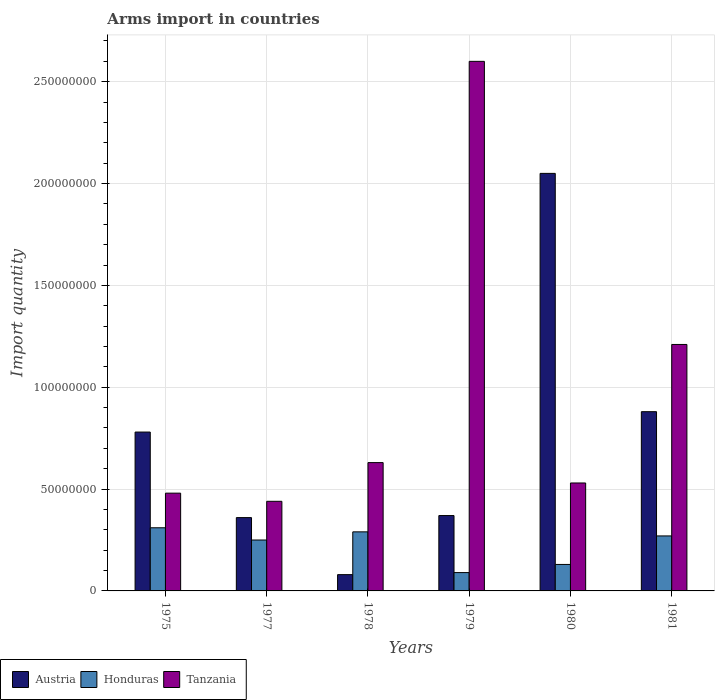Are the number of bars on each tick of the X-axis equal?
Your answer should be compact. Yes. What is the label of the 5th group of bars from the left?
Provide a short and direct response. 1980. In how many cases, is the number of bars for a given year not equal to the number of legend labels?
Offer a terse response. 0. What is the total arms import in Austria in 1977?
Make the answer very short. 3.60e+07. Across all years, what is the maximum total arms import in Tanzania?
Offer a very short reply. 2.60e+08. Across all years, what is the minimum total arms import in Austria?
Offer a terse response. 8.00e+06. In which year was the total arms import in Honduras maximum?
Your answer should be very brief. 1975. In which year was the total arms import in Austria minimum?
Your response must be concise. 1978. What is the total total arms import in Austria in the graph?
Keep it short and to the point. 4.52e+08. What is the difference between the total arms import in Austria in 1977 and that in 1980?
Your answer should be compact. -1.69e+08. What is the difference between the total arms import in Austria in 1977 and the total arms import in Tanzania in 1979?
Provide a succinct answer. -2.24e+08. What is the average total arms import in Austria per year?
Give a very brief answer. 7.53e+07. In the year 1975, what is the difference between the total arms import in Honduras and total arms import in Austria?
Keep it short and to the point. -4.70e+07. What is the ratio of the total arms import in Honduras in 1975 to that in 1978?
Your answer should be compact. 1.07. Is the total arms import in Honduras in 1977 less than that in 1979?
Your answer should be very brief. No. What is the difference between the highest and the second highest total arms import in Austria?
Give a very brief answer. 1.17e+08. What is the difference between the highest and the lowest total arms import in Honduras?
Provide a short and direct response. 2.20e+07. In how many years, is the total arms import in Tanzania greater than the average total arms import in Tanzania taken over all years?
Your response must be concise. 2. Is the sum of the total arms import in Honduras in 1978 and 1980 greater than the maximum total arms import in Tanzania across all years?
Make the answer very short. No. What does the 1st bar from the right in 1979 represents?
Ensure brevity in your answer.  Tanzania. Is it the case that in every year, the sum of the total arms import in Austria and total arms import in Tanzania is greater than the total arms import in Honduras?
Make the answer very short. Yes. How many bars are there?
Your answer should be very brief. 18. How many years are there in the graph?
Ensure brevity in your answer.  6. What is the difference between two consecutive major ticks on the Y-axis?
Your answer should be very brief. 5.00e+07. Does the graph contain grids?
Your answer should be very brief. Yes. Where does the legend appear in the graph?
Your answer should be very brief. Bottom left. How are the legend labels stacked?
Make the answer very short. Horizontal. What is the title of the graph?
Your answer should be very brief. Arms import in countries. What is the label or title of the Y-axis?
Give a very brief answer. Import quantity. What is the Import quantity of Austria in 1975?
Ensure brevity in your answer.  7.80e+07. What is the Import quantity in Honduras in 1975?
Keep it short and to the point. 3.10e+07. What is the Import quantity of Tanzania in 1975?
Offer a very short reply. 4.80e+07. What is the Import quantity in Austria in 1977?
Offer a terse response. 3.60e+07. What is the Import quantity of Honduras in 1977?
Ensure brevity in your answer.  2.50e+07. What is the Import quantity in Tanzania in 1977?
Keep it short and to the point. 4.40e+07. What is the Import quantity of Austria in 1978?
Give a very brief answer. 8.00e+06. What is the Import quantity in Honduras in 1978?
Offer a terse response. 2.90e+07. What is the Import quantity of Tanzania in 1978?
Provide a succinct answer. 6.30e+07. What is the Import quantity of Austria in 1979?
Keep it short and to the point. 3.70e+07. What is the Import quantity in Honduras in 1979?
Provide a succinct answer. 9.00e+06. What is the Import quantity of Tanzania in 1979?
Your response must be concise. 2.60e+08. What is the Import quantity in Austria in 1980?
Provide a short and direct response. 2.05e+08. What is the Import quantity of Honduras in 1980?
Make the answer very short. 1.30e+07. What is the Import quantity of Tanzania in 1980?
Provide a succinct answer. 5.30e+07. What is the Import quantity in Austria in 1981?
Make the answer very short. 8.80e+07. What is the Import quantity of Honduras in 1981?
Offer a very short reply. 2.70e+07. What is the Import quantity of Tanzania in 1981?
Make the answer very short. 1.21e+08. Across all years, what is the maximum Import quantity in Austria?
Provide a succinct answer. 2.05e+08. Across all years, what is the maximum Import quantity of Honduras?
Your answer should be very brief. 3.10e+07. Across all years, what is the maximum Import quantity of Tanzania?
Your response must be concise. 2.60e+08. Across all years, what is the minimum Import quantity of Honduras?
Provide a succinct answer. 9.00e+06. Across all years, what is the minimum Import quantity in Tanzania?
Your answer should be compact. 4.40e+07. What is the total Import quantity of Austria in the graph?
Your answer should be compact. 4.52e+08. What is the total Import quantity of Honduras in the graph?
Your response must be concise. 1.34e+08. What is the total Import quantity in Tanzania in the graph?
Provide a succinct answer. 5.89e+08. What is the difference between the Import quantity in Austria in 1975 and that in 1977?
Ensure brevity in your answer.  4.20e+07. What is the difference between the Import quantity of Tanzania in 1975 and that in 1977?
Keep it short and to the point. 4.00e+06. What is the difference between the Import quantity in Austria in 1975 and that in 1978?
Make the answer very short. 7.00e+07. What is the difference between the Import quantity in Honduras in 1975 and that in 1978?
Offer a terse response. 2.00e+06. What is the difference between the Import quantity in Tanzania in 1975 and that in 1978?
Keep it short and to the point. -1.50e+07. What is the difference between the Import quantity of Austria in 1975 and that in 1979?
Make the answer very short. 4.10e+07. What is the difference between the Import quantity of Honduras in 1975 and that in 1979?
Make the answer very short. 2.20e+07. What is the difference between the Import quantity in Tanzania in 1975 and that in 1979?
Your response must be concise. -2.12e+08. What is the difference between the Import quantity in Austria in 1975 and that in 1980?
Offer a terse response. -1.27e+08. What is the difference between the Import quantity of Honduras in 1975 and that in 1980?
Ensure brevity in your answer.  1.80e+07. What is the difference between the Import quantity in Tanzania in 1975 and that in 1980?
Give a very brief answer. -5.00e+06. What is the difference between the Import quantity in Austria in 1975 and that in 1981?
Your answer should be very brief. -1.00e+07. What is the difference between the Import quantity in Tanzania in 1975 and that in 1981?
Provide a succinct answer. -7.30e+07. What is the difference between the Import quantity of Austria in 1977 and that in 1978?
Offer a terse response. 2.80e+07. What is the difference between the Import quantity of Tanzania in 1977 and that in 1978?
Ensure brevity in your answer.  -1.90e+07. What is the difference between the Import quantity of Austria in 1977 and that in 1979?
Give a very brief answer. -1.00e+06. What is the difference between the Import quantity of Honduras in 1977 and that in 1979?
Make the answer very short. 1.60e+07. What is the difference between the Import quantity in Tanzania in 1977 and that in 1979?
Your answer should be compact. -2.16e+08. What is the difference between the Import quantity of Austria in 1977 and that in 1980?
Give a very brief answer. -1.69e+08. What is the difference between the Import quantity in Honduras in 1977 and that in 1980?
Keep it short and to the point. 1.20e+07. What is the difference between the Import quantity of Tanzania in 1977 and that in 1980?
Your answer should be very brief. -9.00e+06. What is the difference between the Import quantity in Austria in 1977 and that in 1981?
Offer a very short reply. -5.20e+07. What is the difference between the Import quantity in Honduras in 1977 and that in 1981?
Offer a terse response. -2.00e+06. What is the difference between the Import quantity of Tanzania in 1977 and that in 1981?
Give a very brief answer. -7.70e+07. What is the difference between the Import quantity in Austria in 1978 and that in 1979?
Give a very brief answer. -2.90e+07. What is the difference between the Import quantity in Tanzania in 1978 and that in 1979?
Give a very brief answer. -1.97e+08. What is the difference between the Import quantity of Austria in 1978 and that in 1980?
Keep it short and to the point. -1.97e+08. What is the difference between the Import quantity of Honduras in 1978 and that in 1980?
Give a very brief answer. 1.60e+07. What is the difference between the Import quantity of Austria in 1978 and that in 1981?
Give a very brief answer. -8.00e+07. What is the difference between the Import quantity of Tanzania in 1978 and that in 1981?
Your response must be concise. -5.80e+07. What is the difference between the Import quantity of Austria in 1979 and that in 1980?
Give a very brief answer. -1.68e+08. What is the difference between the Import quantity of Tanzania in 1979 and that in 1980?
Offer a very short reply. 2.07e+08. What is the difference between the Import quantity of Austria in 1979 and that in 1981?
Offer a very short reply. -5.10e+07. What is the difference between the Import quantity of Honduras in 1979 and that in 1981?
Offer a very short reply. -1.80e+07. What is the difference between the Import quantity in Tanzania in 1979 and that in 1981?
Ensure brevity in your answer.  1.39e+08. What is the difference between the Import quantity in Austria in 1980 and that in 1981?
Make the answer very short. 1.17e+08. What is the difference between the Import quantity in Honduras in 1980 and that in 1981?
Your answer should be compact. -1.40e+07. What is the difference between the Import quantity in Tanzania in 1980 and that in 1981?
Make the answer very short. -6.80e+07. What is the difference between the Import quantity of Austria in 1975 and the Import quantity of Honduras in 1977?
Your response must be concise. 5.30e+07. What is the difference between the Import quantity of Austria in 1975 and the Import quantity of Tanzania in 1977?
Provide a short and direct response. 3.40e+07. What is the difference between the Import quantity of Honduras in 1975 and the Import quantity of Tanzania in 1977?
Keep it short and to the point. -1.30e+07. What is the difference between the Import quantity in Austria in 1975 and the Import quantity in Honduras in 1978?
Keep it short and to the point. 4.90e+07. What is the difference between the Import quantity of Austria in 1975 and the Import quantity of Tanzania in 1978?
Offer a terse response. 1.50e+07. What is the difference between the Import quantity of Honduras in 1975 and the Import quantity of Tanzania in 1978?
Give a very brief answer. -3.20e+07. What is the difference between the Import quantity of Austria in 1975 and the Import quantity of Honduras in 1979?
Your answer should be compact. 6.90e+07. What is the difference between the Import quantity of Austria in 1975 and the Import quantity of Tanzania in 1979?
Provide a succinct answer. -1.82e+08. What is the difference between the Import quantity in Honduras in 1975 and the Import quantity in Tanzania in 1979?
Offer a terse response. -2.29e+08. What is the difference between the Import quantity in Austria in 1975 and the Import quantity in Honduras in 1980?
Give a very brief answer. 6.50e+07. What is the difference between the Import quantity in Austria in 1975 and the Import quantity in Tanzania in 1980?
Ensure brevity in your answer.  2.50e+07. What is the difference between the Import quantity in Honduras in 1975 and the Import quantity in Tanzania in 1980?
Give a very brief answer. -2.20e+07. What is the difference between the Import quantity in Austria in 1975 and the Import quantity in Honduras in 1981?
Offer a terse response. 5.10e+07. What is the difference between the Import quantity in Austria in 1975 and the Import quantity in Tanzania in 1981?
Offer a terse response. -4.30e+07. What is the difference between the Import quantity in Honduras in 1975 and the Import quantity in Tanzania in 1981?
Give a very brief answer. -9.00e+07. What is the difference between the Import quantity of Austria in 1977 and the Import quantity of Tanzania in 1978?
Offer a terse response. -2.70e+07. What is the difference between the Import quantity of Honduras in 1977 and the Import quantity of Tanzania in 1978?
Ensure brevity in your answer.  -3.80e+07. What is the difference between the Import quantity in Austria in 1977 and the Import quantity in Honduras in 1979?
Offer a very short reply. 2.70e+07. What is the difference between the Import quantity in Austria in 1977 and the Import quantity in Tanzania in 1979?
Make the answer very short. -2.24e+08. What is the difference between the Import quantity in Honduras in 1977 and the Import quantity in Tanzania in 1979?
Offer a terse response. -2.35e+08. What is the difference between the Import quantity of Austria in 1977 and the Import quantity of Honduras in 1980?
Make the answer very short. 2.30e+07. What is the difference between the Import quantity of Austria in 1977 and the Import quantity of Tanzania in 1980?
Keep it short and to the point. -1.70e+07. What is the difference between the Import quantity of Honduras in 1977 and the Import quantity of Tanzania in 1980?
Offer a very short reply. -2.80e+07. What is the difference between the Import quantity in Austria in 1977 and the Import quantity in Honduras in 1981?
Your answer should be very brief. 9.00e+06. What is the difference between the Import quantity in Austria in 1977 and the Import quantity in Tanzania in 1981?
Your response must be concise. -8.50e+07. What is the difference between the Import quantity in Honduras in 1977 and the Import quantity in Tanzania in 1981?
Make the answer very short. -9.60e+07. What is the difference between the Import quantity of Austria in 1978 and the Import quantity of Tanzania in 1979?
Give a very brief answer. -2.52e+08. What is the difference between the Import quantity of Honduras in 1978 and the Import quantity of Tanzania in 1979?
Your answer should be very brief. -2.31e+08. What is the difference between the Import quantity in Austria in 1978 and the Import quantity in Honduras in 1980?
Provide a succinct answer. -5.00e+06. What is the difference between the Import quantity in Austria in 1978 and the Import quantity in Tanzania in 1980?
Ensure brevity in your answer.  -4.50e+07. What is the difference between the Import quantity of Honduras in 1978 and the Import quantity of Tanzania in 1980?
Provide a succinct answer. -2.40e+07. What is the difference between the Import quantity in Austria in 1978 and the Import quantity in Honduras in 1981?
Ensure brevity in your answer.  -1.90e+07. What is the difference between the Import quantity in Austria in 1978 and the Import quantity in Tanzania in 1981?
Ensure brevity in your answer.  -1.13e+08. What is the difference between the Import quantity of Honduras in 1978 and the Import quantity of Tanzania in 1981?
Provide a short and direct response. -9.20e+07. What is the difference between the Import quantity in Austria in 1979 and the Import quantity in Honduras in 1980?
Your response must be concise. 2.40e+07. What is the difference between the Import quantity of Austria in 1979 and the Import quantity of Tanzania in 1980?
Give a very brief answer. -1.60e+07. What is the difference between the Import quantity of Honduras in 1979 and the Import quantity of Tanzania in 1980?
Offer a very short reply. -4.40e+07. What is the difference between the Import quantity in Austria in 1979 and the Import quantity in Honduras in 1981?
Ensure brevity in your answer.  1.00e+07. What is the difference between the Import quantity of Austria in 1979 and the Import quantity of Tanzania in 1981?
Your response must be concise. -8.40e+07. What is the difference between the Import quantity in Honduras in 1979 and the Import quantity in Tanzania in 1981?
Make the answer very short. -1.12e+08. What is the difference between the Import quantity of Austria in 1980 and the Import quantity of Honduras in 1981?
Ensure brevity in your answer.  1.78e+08. What is the difference between the Import quantity in Austria in 1980 and the Import quantity in Tanzania in 1981?
Offer a very short reply. 8.40e+07. What is the difference between the Import quantity in Honduras in 1980 and the Import quantity in Tanzania in 1981?
Give a very brief answer. -1.08e+08. What is the average Import quantity of Austria per year?
Provide a succinct answer. 7.53e+07. What is the average Import quantity of Honduras per year?
Your answer should be very brief. 2.23e+07. What is the average Import quantity in Tanzania per year?
Offer a very short reply. 9.82e+07. In the year 1975, what is the difference between the Import quantity of Austria and Import quantity of Honduras?
Your answer should be very brief. 4.70e+07. In the year 1975, what is the difference between the Import quantity in Austria and Import quantity in Tanzania?
Make the answer very short. 3.00e+07. In the year 1975, what is the difference between the Import quantity in Honduras and Import quantity in Tanzania?
Your answer should be very brief. -1.70e+07. In the year 1977, what is the difference between the Import quantity in Austria and Import quantity in Honduras?
Keep it short and to the point. 1.10e+07. In the year 1977, what is the difference between the Import quantity in Austria and Import quantity in Tanzania?
Provide a short and direct response. -8.00e+06. In the year 1977, what is the difference between the Import quantity of Honduras and Import quantity of Tanzania?
Your answer should be very brief. -1.90e+07. In the year 1978, what is the difference between the Import quantity in Austria and Import quantity in Honduras?
Ensure brevity in your answer.  -2.10e+07. In the year 1978, what is the difference between the Import quantity in Austria and Import quantity in Tanzania?
Keep it short and to the point. -5.50e+07. In the year 1978, what is the difference between the Import quantity in Honduras and Import quantity in Tanzania?
Your answer should be compact. -3.40e+07. In the year 1979, what is the difference between the Import quantity of Austria and Import quantity of Honduras?
Provide a succinct answer. 2.80e+07. In the year 1979, what is the difference between the Import quantity of Austria and Import quantity of Tanzania?
Provide a short and direct response. -2.23e+08. In the year 1979, what is the difference between the Import quantity of Honduras and Import quantity of Tanzania?
Your answer should be very brief. -2.51e+08. In the year 1980, what is the difference between the Import quantity of Austria and Import quantity of Honduras?
Ensure brevity in your answer.  1.92e+08. In the year 1980, what is the difference between the Import quantity in Austria and Import quantity in Tanzania?
Keep it short and to the point. 1.52e+08. In the year 1980, what is the difference between the Import quantity in Honduras and Import quantity in Tanzania?
Offer a terse response. -4.00e+07. In the year 1981, what is the difference between the Import quantity in Austria and Import quantity in Honduras?
Keep it short and to the point. 6.10e+07. In the year 1981, what is the difference between the Import quantity of Austria and Import quantity of Tanzania?
Your answer should be very brief. -3.30e+07. In the year 1981, what is the difference between the Import quantity of Honduras and Import quantity of Tanzania?
Give a very brief answer. -9.40e+07. What is the ratio of the Import quantity in Austria in 1975 to that in 1977?
Provide a short and direct response. 2.17. What is the ratio of the Import quantity of Honduras in 1975 to that in 1977?
Your answer should be very brief. 1.24. What is the ratio of the Import quantity in Tanzania in 1975 to that in 1977?
Provide a succinct answer. 1.09. What is the ratio of the Import quantity in Austria in 1975 to that in 1978?
Offer a terse response. 9.75. What is the ratio of the Import quantity of Honduras in 1975 to that in 1978?
Ensure brevity in your answer.  1.07. What is the ratio of the Import quantity of Tanzania in 1975 to that in 1978?
Your answer should be very brief. 0.76. What is the ratio of the Import quantity in Austria in 1975 to that in 1979?
Your response must be concise. 2.11. What is the ratio of the Import quantity in Honduras in 1975 to that in 1979?
Make the answer very short. 3.44. What is the ratio of the Import quantity in Tanzania in 1975 to that in 1979?
Provide a succinct answer. 0.18. What is the ratio of the Import quantity in Austria in 1975 to that in 1980?
Give a very brief answer. 0.38. What is the ratio of the Import quantity in Honduras in 1975 to that in 1980?
Offer a terse response. 2.38. What is the ratio of the Import quantity of Tanzania in 1975 to that in 1980?
Offer a terse response. 0.91. What is the ratio of the Import quantity in Austria in 1975 to that in 1981?
Your answer should be very brief. 0.89. What is the ratio of the Import quantity in Honduras in 1975 to that in 1981?
Your answer should be very brief. 1.15. What is the ratio of the Import quantity of Tanzania in 1975 to that in 1981?
Keep it short and to the point. 0.4. What is the ratio of the Import quantity in Austria in 1977 to that in 1978?
Your answer should be compact. 4.5. What is the ratio of the Import quantity in Honduras in 1977 to that in 1978?
Your answer should be very brief. 0.86. What is the ratio of the Import quantity in Tanzania in 1977 to that in 1978?
Make the answer very short. 0.7. What is the ratio of the Import quantity of Austria in 1977 to that in 1979?
Provide a succinct answer. 0.97. What is the ratio of the Import quantity of Honduras in 1977 to that in 1979?
Keep it short and to the point. 2.78. What is the ratio of the Import quantity in Tanzania in 1977 to that in 1979?
Offer a very short reply. 0.17. What is the ratio of the Import quantity of Austria in 1977 to that in 1980?
Make the answer very short. 0.18. What is the ratio of the Import quantity of Honduras in 1977 to that in 1980?
Provide a short and direct response. 1.92. What is the ratio of the Import quantity of Tanzania in 1977 to that in 1980?
Keep it short and to the point. 0.83. What is the ratio of the Import quantity in Austria in 1977 to that in 1981?
Give a very brief answer. 0.41. What is the ratio of the Import quantity of Honduras in 1977 to that in 1981?
Provide a succinct answer. 0.93. What is the ratio of the Import quantity of Tanzania in 1977 to that in 1981?
Offer a very short reply. 0.36. What is the ratio of the Import quantity in Austria in 1978 to that in 1979?
Give a very brief answer. 0.22. What is the ratio of the Import quantity in Honduras in 1978 to that in 1979?
Provide a succinct answer. 3.22. What is the ratio of the Import quantity in Tanzania in 1978 to that in 1979?
Give a very brief answer. 0.24. What is the ratio of the Import quantity in Austria in 1978 to that in 1980?
Make the answer very short. 0.04. What is the ratio of the Import quantity of Honduras in 1978 to that in 1980?
Ensure brevity in your answer.  2.23. What is the ratio of the Import quantity of Tanzania in 1978 to that in 1980?
Offer a very short reply. 1.19. What is the ratio of the Import quantity of Austria in 1978 to that in 1981?
Give a very brief answer. 0.09. What is the ratio of the Import quantity in Honduras in 1978 to that in 1981?
Your response must be concise. 1.07. What is the ratio of the Import quantity in Tanzania in 1978 to that in 1981?
Offer a very short reply. 0.52. What is the ratio of the Import quantity of Austria in 1979 to that in 1980?
Your response must be concise. 0.18. What is the ratio of the Import quantity in Honduras in 1979 to that in 1980?
Offer a terse response. 0.69. What is the ratio of the Import quantity in Tanzania in 1979 to that in 1980?
Provide a succinct answer. 4.91. What is the ratio of the Import quantity of Austria in 1979 to that in 1981?
Your answer should be very brief. 0.42. What is the ratio of the Import quantity of Honduras in 1979 to that in 1981?
Give a very brief answer. 0.33. What is the ratio of the Import quantity of Tanzania in 1979 to that in 1981?
Ensure brevity in your answer.  2.15. What is the ratio of the Import quantity of Austria in 1980 to that in 1981?
Your answer should be compact. 2.33. What is the ratio of the Import quantity of Honduras in 1980 to that in 1981?
Your response must be concise. 0.48. What is the ratio of the Import quantity in Tanzania in 1980 to that in 1981?
Your response must be concise. 0.44. What is the difference between the highest and the second highest Import quantity in Austria?
Provide a succinct answer. 1.17e+08. What is the difference between the highest and the second highest Import quantity of Tanzania?
Make the answer very short. 1.39e+08. What is the difference between the highest and the lowest Import quantity in Austria?
Provide a short and direct response. 1.97e+08. What is the difference between the highest and the lowest Import quantity of Honduras?
Provide a succinct answer. 2.20e+07. What is the difference between the highest and the lowest Import quantity in Tanzania?
Provide a short and direct response. 2.16e+08. 